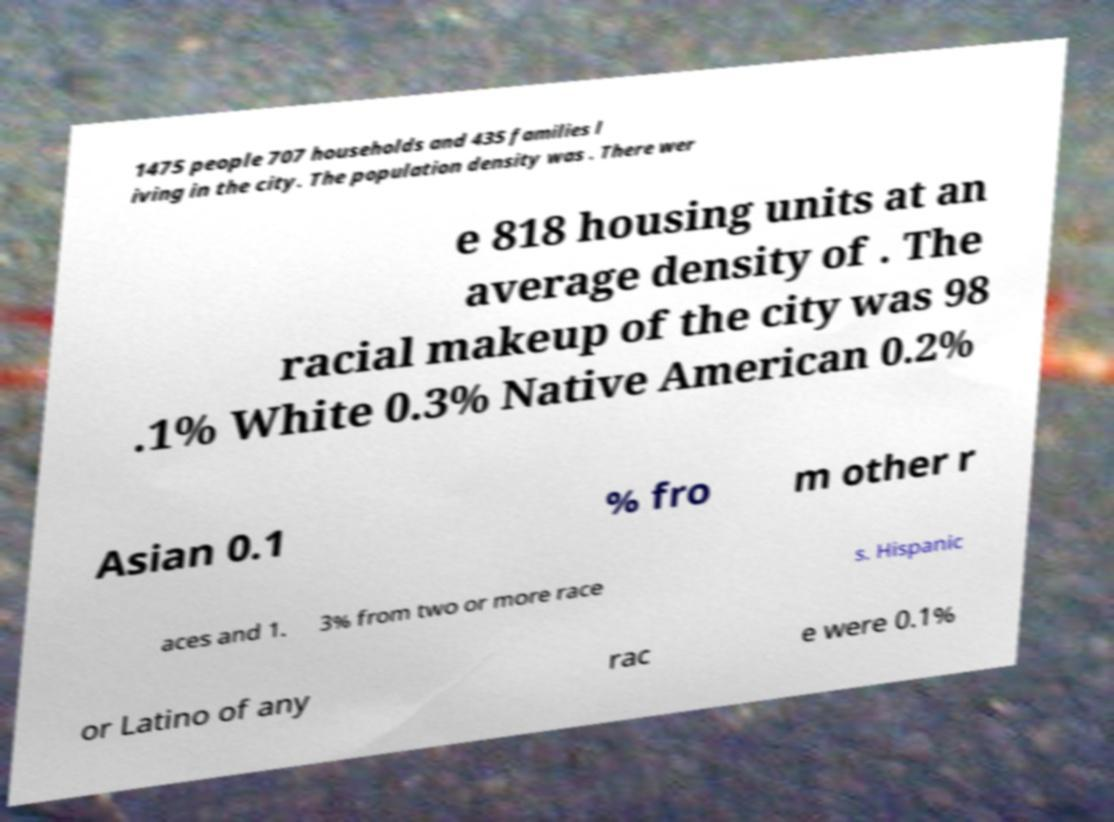Please identify and transcribe the text found in this image. 1475 people 707 households and 435 families l iving in the city. The population density was . There wer e 818 housing units at an average density of . The racial makeup of the city was 98 .1% White 0.3% Native American 0.2% Asian 0.1 % fro m other r aces and 1. 3% from two or more race s. Hispanic or Latino of any rac e were 0.1% 